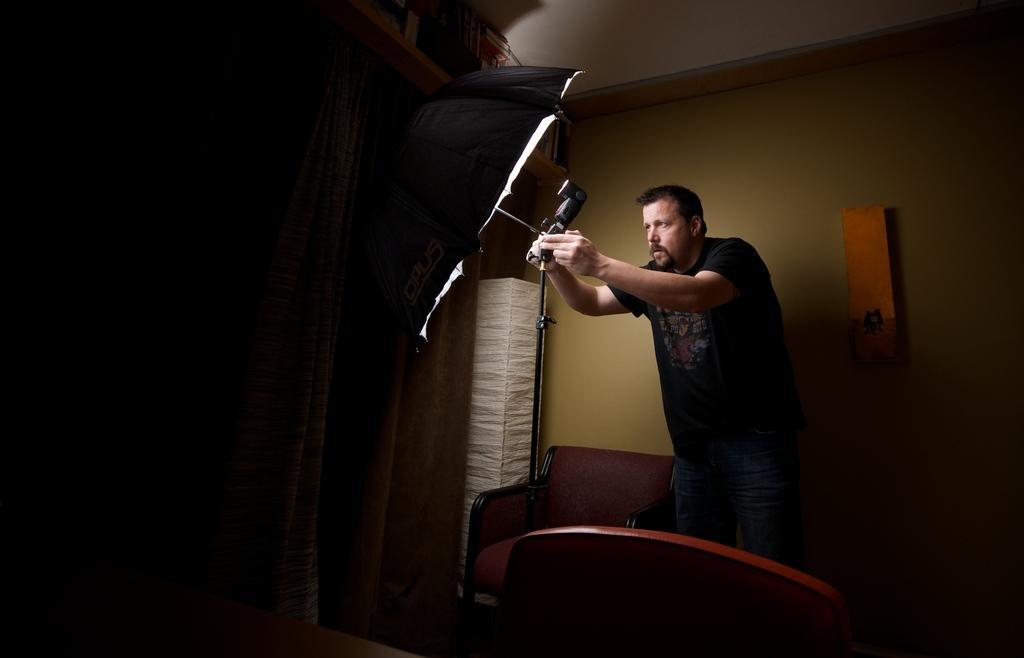How would you summarize this image in a sentence or two? In this picture we can see a man who is holding an umbrella. These are the chairs and there is a wall. 